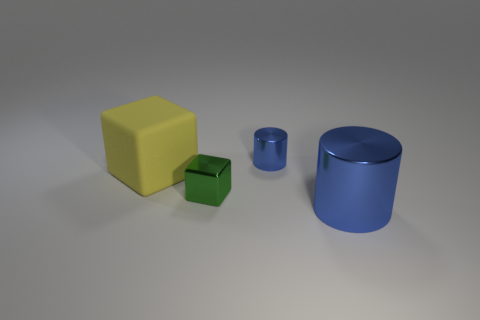Add 3 tiny green metal blocks. How many objects exist? 7 Subtract all large things. Subtract all cyan cylinders. How many objects are left? 2 Add 4 metallic objects. How many metallic objects are left? 7 Add 4 big blue cylinders. How many big blue cylinders exist? 5 Subtract 0 gray cylinders. How many objects are left? 4 